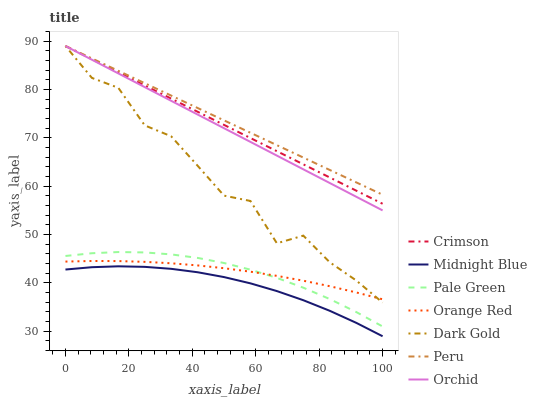Does Midnight Blue have the minimum area under the curve?
Answer yes or no. Yes. Does Peru have the maximum area under the curve?
Answer yes or no. Yes. Does Dark Gold have the minimum area under the curve?
Answer yes or no. No. Does Dark Gold have the maximum area under the curve?
Answer yes or no. No. Is Orchid the smoothest?
Answer yes or no. Yes. Is Dark Gold the roughest?
Answer yes or no. Yes. Is Pale Green the smoothest?
Answer yes or no. No. Is Pale Green the roughest?
Answer yes or no. No. Does Dark Gold have the lowest value?
Answer yes or no. No. Does Orchid have the highest value?
Answer yes or no. Yes. Does Pale Green have the highest value?
Answer yes or no. No. Is Midnight Blue less than Orange Red?
Answer yes or no. Yes. Is Crimson greater than Pale Green?
Answer yes or no. Yes. Does Dark Gold intersect Orchid?
Answer yes or no. Yes. Is Dark Gold less than Orchid?
Answer yes or no. No. Is Dark Gold greater than Orchid?
Answer yes or no. No. Does Midnight Blue intersect Orange Red?
Answer yes or no. No. 